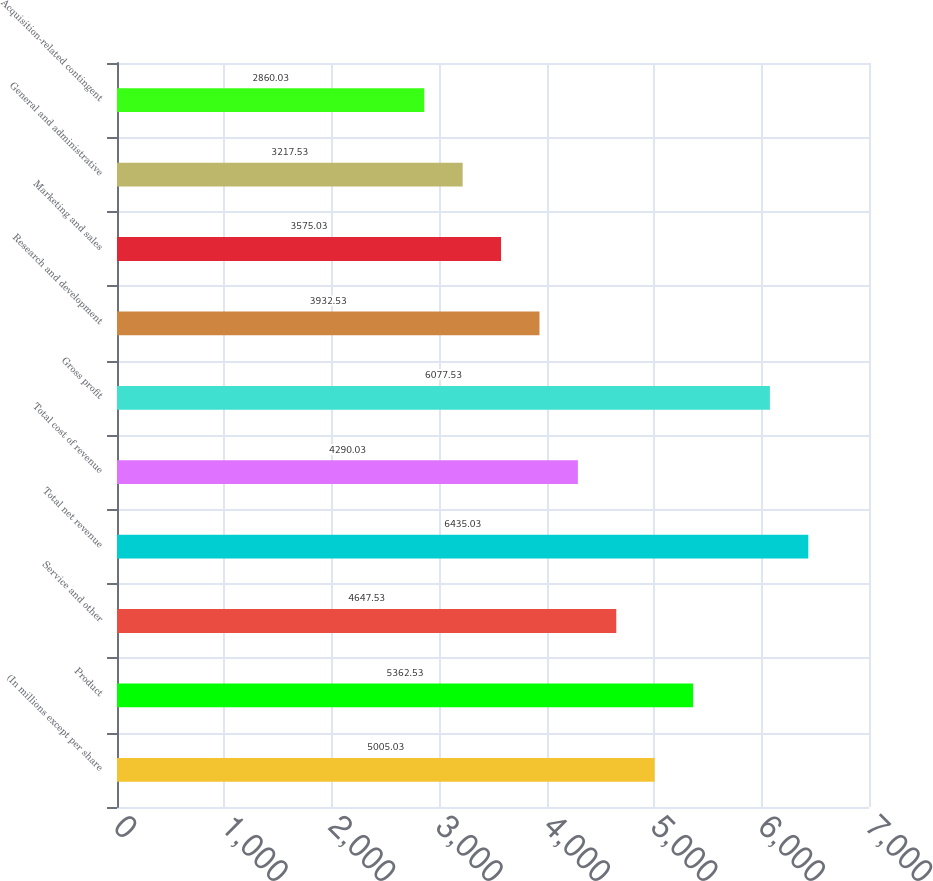Convert chart to OTSL. <chart><loc_0><loc_0><loc_500><loc_500><bar_chart><fcel>(In millions except per share<fcel>Product<fcel>Service and other<fcel>Total net revenue<fcel>Total cost of revenue<fcel>Gross profit<fcel>Research and development<fcel>Marketing and sales<fcel>General and administrative<fcel>Acquisition-related contingent<nl><fcel>5005.03<fcel>5362.53<fcel>4647.53<fcel>6435.03<fcel>4290.03<fcel>6077.53<fcel>3932.53<fcel>3575.03<fcel>3217.53<fcel>2860.03<nl></chart> 